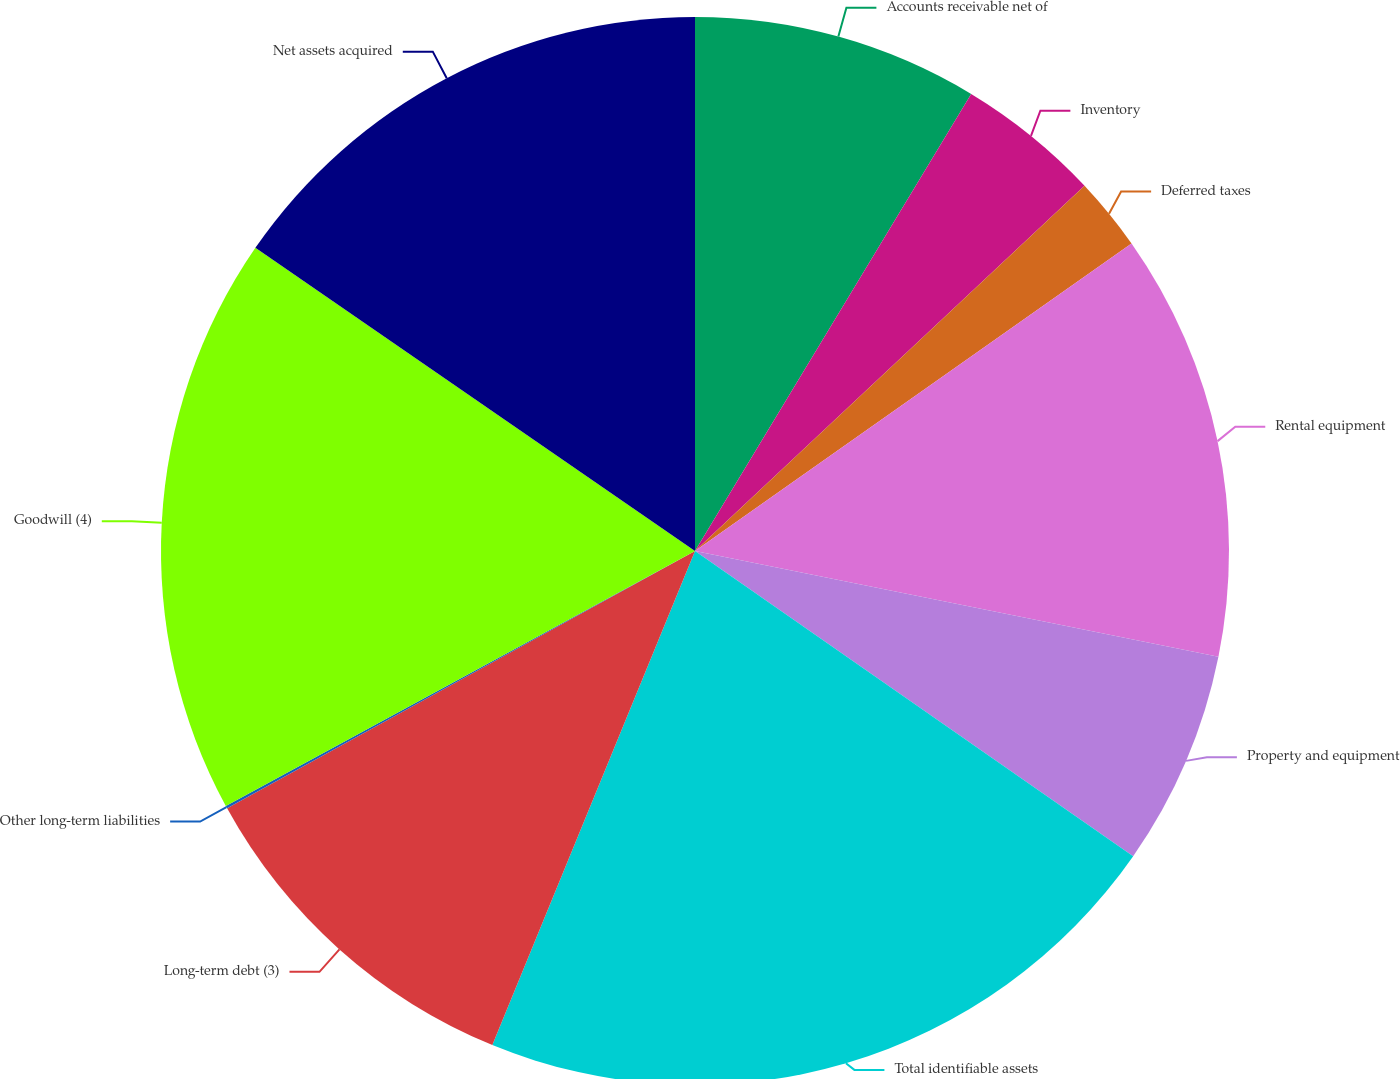Convert chart to OTSL. <chart><loc_0><loc_0><loc_500><loc_500><pie_chart><fcel>Accounts receivable net of<fcel>Inventory<fcel>Deferred taxes<fcel>Rental equipment<fcel>Property and equipment<fcel>Total identifiable assets<fcel>Long-term debt (3)<fcel>Other long-term liabilities<fcel>Goodwill (4)<fcel>Net assets acquired<nl><fcel>8.65%<fcel>4.36%<fcel>2.22%<fcel>12.94%<fcel>6.51%<fcel>21.51%<fcel>10.8%<fcel>0.08%<fcel>17.53%<fcel>15.39%<nl></chart> 